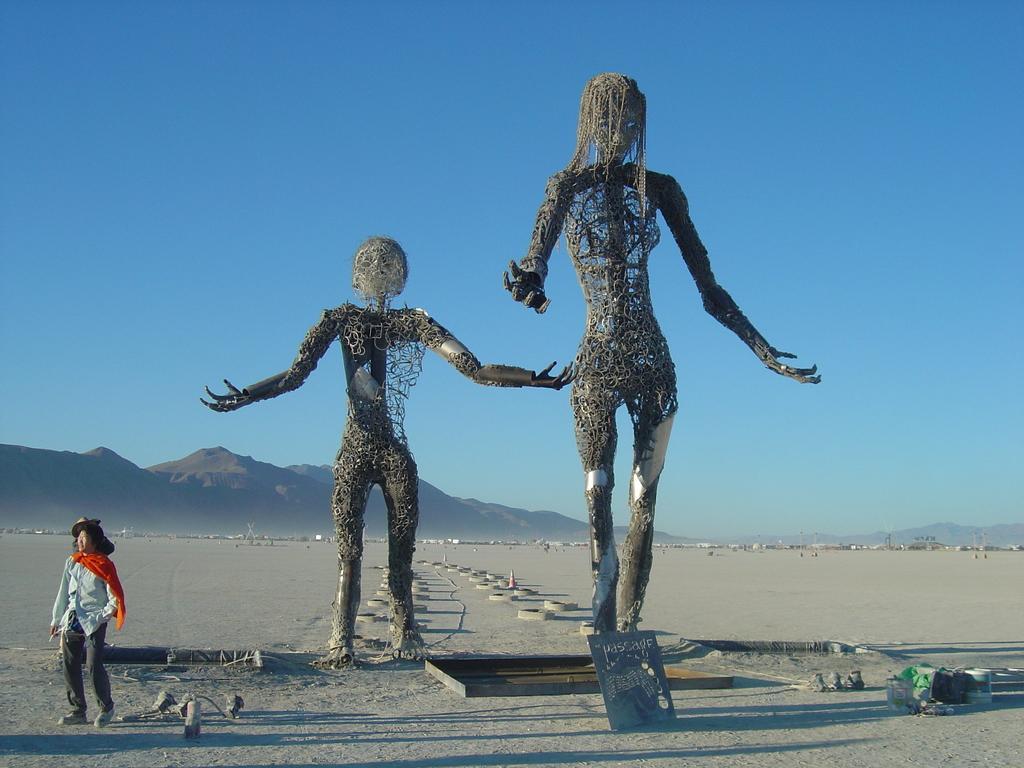How would you summarize this image in a sentence or two? In this image we can see two sculptures and a person, there are some objects and mountains, in the background we can see the sky. 